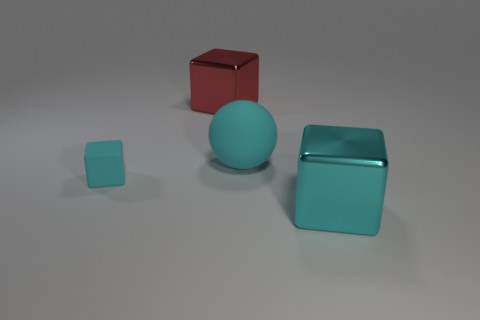Can you describe the colors and shapes of the objects presented in the image? Certainly! In the image, there are four objects with distinct shapes and colors. There's a small aqua cube, a large cyan matte cube, a spherical object with a teal hue, and a glossy red cube. These items display a variety of geometric forms with a cohesive, pastel color palette. 